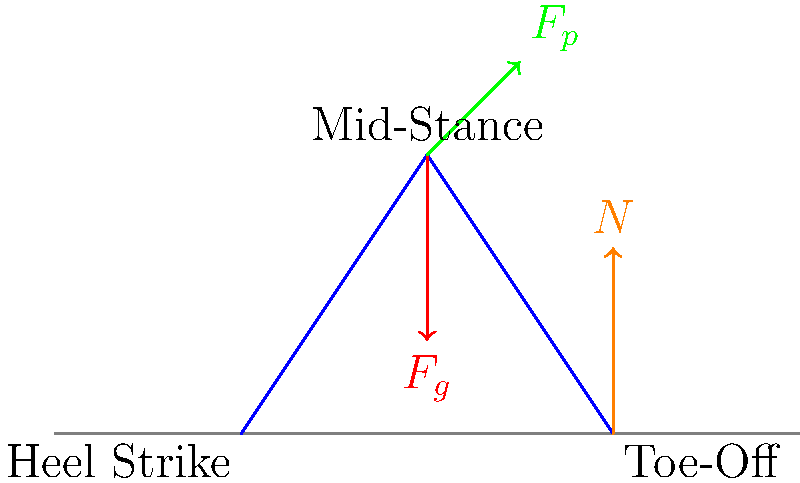In the diagram above, which force represented by the vectors acting on the runner's leg during the mid-stance phase is most likely responsible for propelling the runner forward? To answer this question, let's analyze the forces acting on the runner's leg during the mid-stance phase:

1. $F_g$ (red vector): This represents the force of gravity acting downward on the runner's center of mass.

2. $F_p$ (green vector): This diagonal vector represents the propulsive force generated by the runner's muscles.

3. $N$ (orange vector): This represents the normal force from the ground, which is not present at the mid-stance point but is shown at the toe-off phase.

The force most responsible for propelling the runner forward is $F_p$. Here's why:

1. The gravitational force $F_g$ acts vertically downward and does not contribute to forward motion.

2. The normal force $N$ is not present at the mid-stance point and mainly counteracts gravity during ground contact.

3. The propulsive force $F_p$ is angled forward and upward. This force is generated by the runner's muscles, particularly the calf muscles and quadriceps, as they contract to extend the leg.

The horizontal component of $F_p$ is what drives the runner forward, while the vertical component helps to overcome gravity and maintain the runner's height.

In the context of biomechanics, this propulsive force is crucial for maintaining and increasing running speed. It's the result of the runner actively pushing against the ground, converting muscular energy into forward motion.
Answer: $F_p$ (propulsive force) 